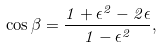<formula> <loc_0><loc_0><loc_500><loc_500>\cos \beta = \frac { 1 + \epsilon ^ { 2 } - 2 \epsilon } { 1 - \epsilon ^ { 2 } } ,</formula> 